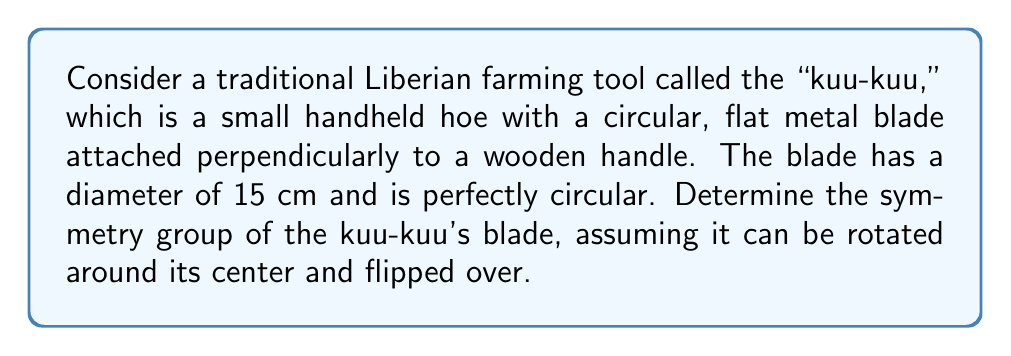Show me your answer to this math problem. Let's approach this step-by-step:

1) First, we need to identify the symmetries of the circular blade:
   a) Rotational symmetry: The blade can be rotated by any angle around its center.
   b) Reflection symmetry: The blade can be flipped over any line passing through its center.

2) The rotational symmetries form a continuous group, as the blade can be rotated by any angle $\theta \in [0, 2\pi)$. This is isomorphic to the group $SO(2)$, the special orthogonal group in 2 dimensions.

3) The reflection symmetries correspond to flipping the blade over any diameter. This generates a group isomorphic to $O(2)/SO(2)$, where $O(2)$ is the orthogonal group in 2 dimensions.

4) The full symmetry group combines both rotations and reflections. This is precisely the definition of the orthogonal group $O(2)$.

5) In group theory notation, we can write this as:

   $$O(2) = \{R_\theta, F_\phi : \theta \in [0, 2\pi), \phi \in [0, \pi)\}$$

   where $R_\theta$ represents a rotation by angle $\theta$, and $F_\phi$ represents a reflection across the line making an angle $\phi$ with the x-axis.

6) The order of this group is infinite, as it contains rotations by any real angle in $[0, 2\pi)$.

Therefore, the symmetry group of the kuu-kuu's blade is the orthogonal group $O(2)$.
Answer: $O(2)$ 